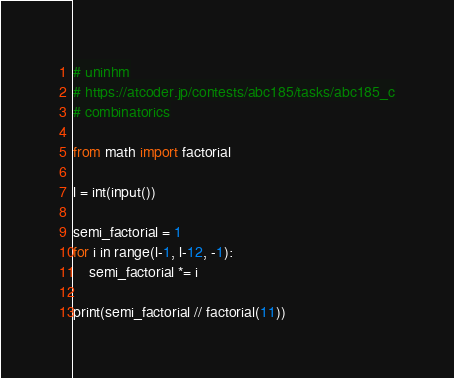Convert code to text. <code><loc_0><loc_0><loc_500><loc_500><_Python_># uninhm
# https://atcoder.jp/contests/abc185/tasks/abc185_c
# combinatorics

from math import factorial

l = int(input())

semi_factorial = 1
for i in range(l-1, l-12, -1):
    semi_factorial *= i

print(semi_factorial // factorial(11))
</code> 